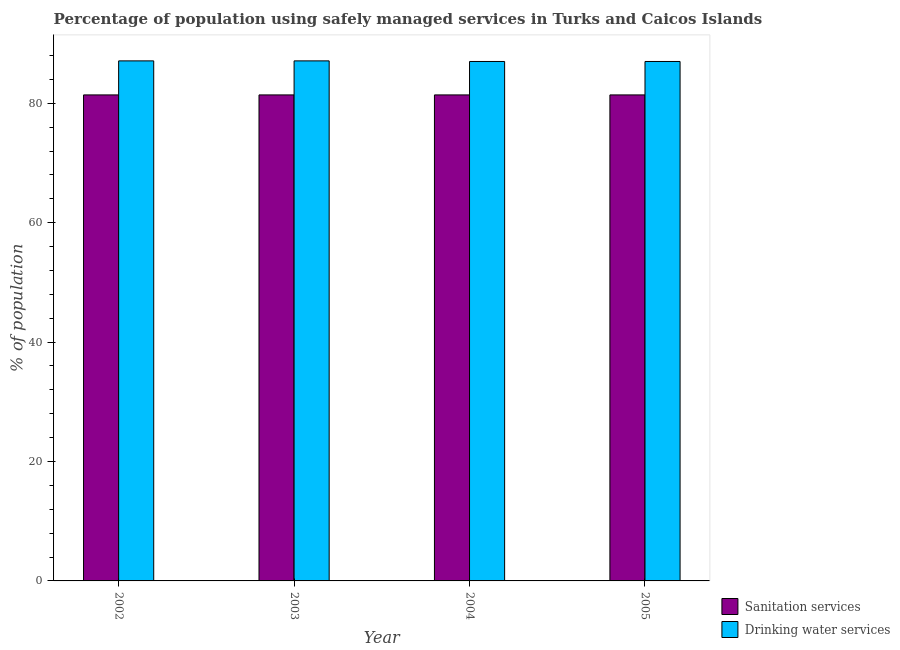Are the number of bars on each tick of the X-axis equal?
Provide a succinct answer. Yes. How many bars are there on the 2nd tick from the left?
Offer a terse response. 2. How many bars are there on the 2nd tick from the right?
Ensure brevity in your answer.  2. In how many cases, is the number of bars for a given year not equal to the number of legend labels?
Provide a short and direct response. 0. What is the percentage of population who used sanitation services in 2004?
Keep it short and to the point. 81.4. Across all years, what is the maximum percentage of population who used sanitation services?
Your answer should be compact. 81.4. Across all years, what is the minimum percentage of population who used drinking water services?
Your response must be concise. 87. What is the total percentage of population who used drinking water services in the graph?
Ensure brevity in your answer.  348.2. What is the difference between the percentage of population who used sanitation services in 2002 and that in 2003?
Offer a very short reply. 0. What is the difference between the percentage of population who used drinking water services in 2005 and the percentage of population who used sanitation services in 2004?
Your answer should be very brief. 0. What is the average percentage of population who used drinking water services per year?
Make the answer very short. 87.05. In the year 2003, what is the difference between the percentage of population who used drinking water services and percentage of population who used sanitation services?
Your response must be concise. 0. In how many years, is the percentage of population who used drinking water services greater than 28 %?
Your answer should be very brief. 4. What is the ratio of the percentage of population who used sanitation services in 2003 to that in 2005?
Provide a short and direct response. 1. What is the difference between the highest and the second highest percentage of population who used drinking water services?
Provide a short and direct response. 0. What is the difference between the highest and the lowest percentage of population who used drinking water services?
Provide a succinct answer. 0.1. Is the sum of the percentage of population who used sanitation services in 2002 and 2004 greater than the maximum percentage of population who used drinking water services across all years?
Give a very brief answer. Yes. What does the 2nd bar from the left in 2002 represents?
Ensure brevity in your answer.  Drinking water services. What does the 2nd bar from the right in 2002 represents?
Ensure brevity in your answer.  Sanitation services. Are all the bars in the graph horizontal?
Offer a terse response. No. How many years are there in the graph?
Provide a succinct answer. 4. What is the difference between two consecutive major ticks on the Y-axis?
Your answer should be very brief. 20. Does the graph contain any zero values?
Your answer should be very brief. No. Does the graph contain grids?
Keep it short and to the point. No. How many legend labels are there?
Give a very brief answer. 2. What is the title of the graph?
Your answer should be very brief. Percentage of population using safely managed services in Turks and Caicos Islands. What is the label or title of the X-axis?
Ensure brevity in your answer.  Year. What is the label or title of the Y-axis?
Offer a terse response. % of population. What is the % of population of Sanitation services in 2002?
Make the answer very short. 81.4. What is the % of population in Drinking water services in 2002?
Your answer should be compact. 87.1. What is the % of population of Sanitation services in 2003?
Keep it short and to the point. 81.4. What is the % of population of Drinking water services in 2003?
Give a very brief answer. 87.1. What is the % of population in Sanitation services in 2004?
Keep it short and to the point. 81.4. What is the % of population of Drinking water services in 2004?
Ensure brevity in your answer.  87. What is the % of population in Sanitation services in 2005?
Offer a terse response. 81.4. What is the % of population of Drinking water services in 2005?
Provide a short and direct response. 87. Across all years, what is the maximum % of population of Sanitation services?
Provide a succinct answer. 81.4. Across all years, what is the maximum % of population of Drinking water services?
Keep it short and to the point. 87.1. Across all years, what is the minimum % of population in Sanitation services?
Provide a succinct answer. 81.4. What is the total % of population of Sanitation services in the graph?
Your answer should be compact. 325.6. What is the total % of population in Drinking water services in the graph?
Give a very brief answer. 348.2. What is the difference between the % of population of Sanitation services in 2002 and that in 2003?
Provide a succinct answer. 0. What is the difference between the % of population in Drinking water services in 2002 and that in 2003?
Provide a succinct answer. 0. What is the difference between the % of population in Drinking water services in 2002 and that in 2005?
Your response must be concise. 0.1. What is the difference between the % of population in Drinking water services in 2004 and that in 2005?
Make the answer very short. 0. What is the difference between the % of population in Sanitation services in 2002 and the % of population in Drinking water services in 2004?
Keep it short and to the point. -5.6. What is the difference between the % of population in Sanitation services in 2002 and the % of population in Drinking water services in 2005?
Make the answer very short. -5.6. What is the average % of population of Sanitation services per year?
Keep it short and to the point. 81.4. What is the average % of population of Drinking water services per year?
Give a very brief answer. 87.05. In the year 2004, what is the difference between the % of population in Sanitation services and % of population in Drinking water services?
Make the answer very short. -5.6. In the year 2005, what is the difference between the % of population of Sanitation services and % of population of Drinking water services?
Offer a terse response. -5.6. What is the ratio of the % of population in Sanitation services in 2002 to that in 2003?
Give a very brief answer. 1. What is the ratio of the % of population in Drinking water services in 2002 to that in 2005?
Ensure brevity in your answer.  1. What is the ratio of the % of population of Drinking water services in 2003 to that in 2004?
Your answer should be compact. 1. What is the ratio of the % of population in Sanitation services in 2003 to that in 2005?
Your answer should be very brief. 1. What is the ratio of the % of population in Sanitation services in 2004 to that in 2005?
Keep it short and to the point. 1. What is the ratio of the % of population of Drinking water services in 2004 to that in 2005?
Your response must be concise. 1. What is the difference between the highest and the second highest % of population of Sanitation services?
Your answer should be compact. 0. What is the difference between the highest and the lowest % of population in Drinking water services?
Provide a short and direct response. 0.1. 